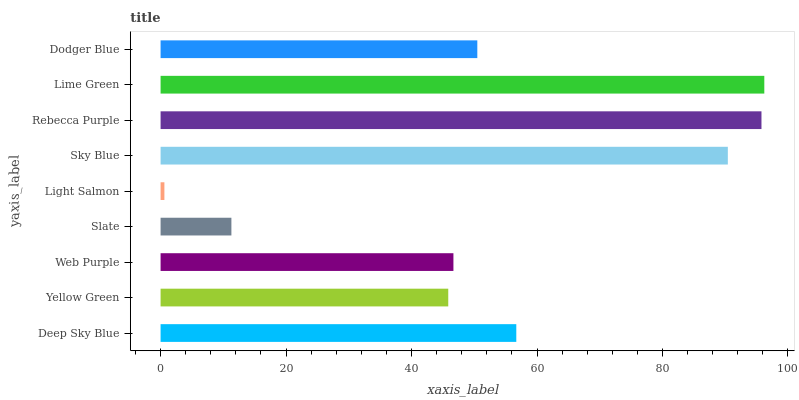Is Light Salmon the minimum?
Answer yes or no. Yes. Is Lime Green the maximum?
Answer yes or no. Yes. Is Yellow Green the minimum?
Answer yes or no. No. Is Yellow Green the maximum?
Answer yes or no. No. Is Deep Sky Blue greater than Yellow Green?
Answer yes or no. Yes. Is Yellow Green less than Deep Sky Blue?
Answer yes or no. Yes. Is Yellow Green greater than Deep Sky Blue?
Answer yes or no. No. Is Deep Sky Blue less than Yellow Green?
Answer yes or no. No. Is Dodger Blue the high median?
Answer yes or no. Yes. Is Dodger Blue the low median?
Answer yes or no. Yes. Is Yellow Green the high median?
Answer yes or no. No. Is Yellow Green the low median?
Answer yes or no. No. 